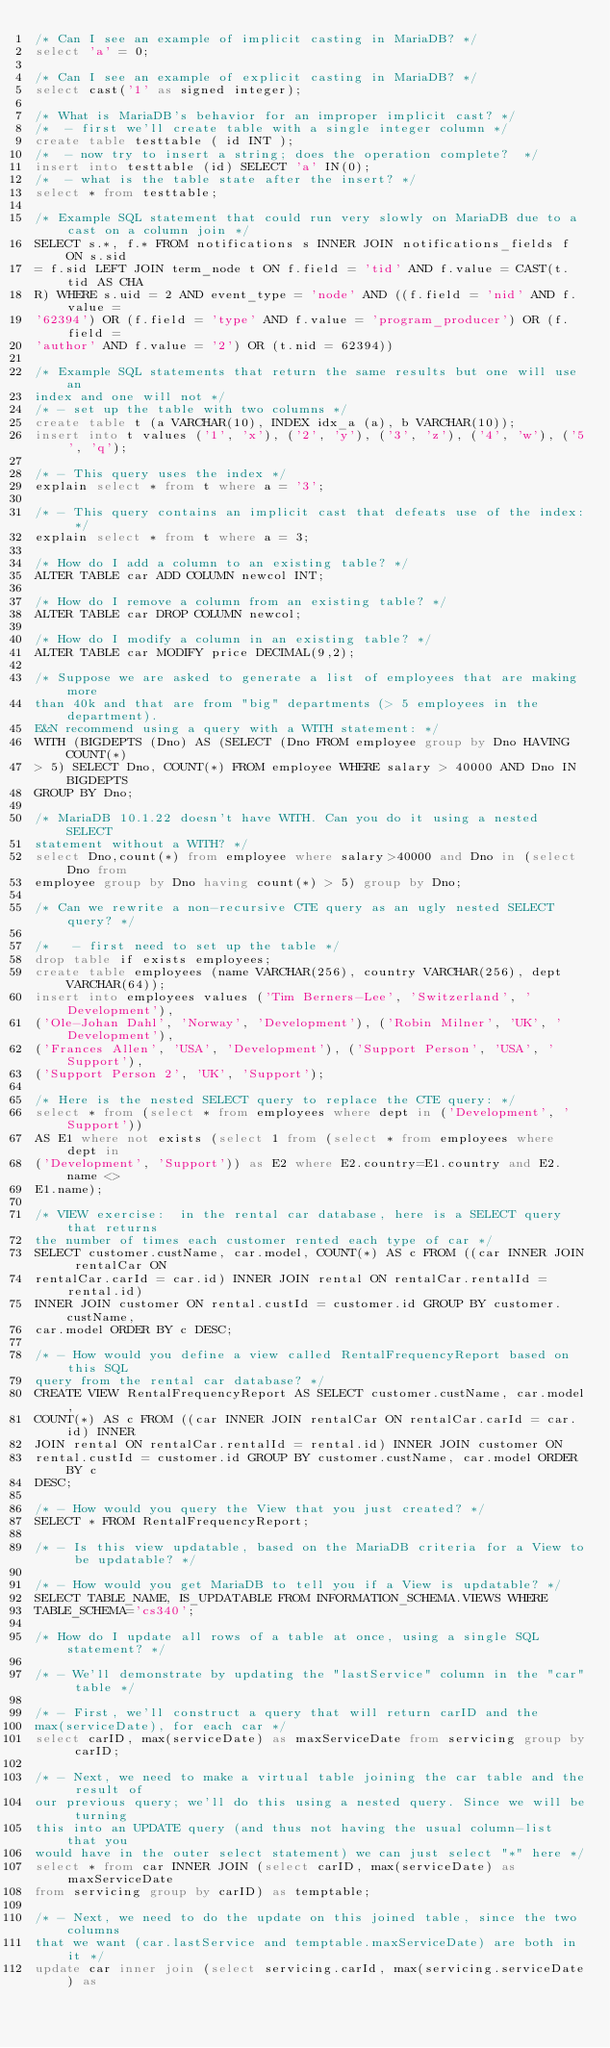<code> <loc_0><loc_0><loc_500><loc_500><_SQL_>/* Can I see an example of implicit casting in MariaDB? */
select 'a' = 0;

/* Can I see an example of explicit casting in MariaDB? */
select cast('1' as signed integer);

/* What is MariaDB's behavior for an improper implicit cast? */
/*  - first we'll create table with a single integer column */
create table testtable ( id INT );
/*  - now try to insert a string; does the operation complete?  */
insert into testtable (id) SELECT 'a' IN(0);
/*  - what is the table state after the insert? */
select * from testtable;

/* Example SQL statement that could run very slowly on MariaDB due to a cast on a column join */
SELECT s.*, f.* FROM notifications s INNER JOIN notifications_fields f ON s.sid
= f.sid LEFT JOIN term_node t ON f.field = 'tid' AND f.value = CAST(t.tid AS CHA
R) WHERE s.uid = 2 AND event_type = 'node' AND ((f.field = 'nid' AND f.value =
'62394') OR (f.field = 'type' AND f.value = 'program_producer') OR (f.field =
'author' AND f.value = '2') OR (t.nid = 62394))

/* Example SQL statements that return the same results but one will use an
index and one will not */
/* - set up the table with two columns */
create table t (a VARCHAR(10), INDEX idx_a (a), b VARCHAR(10));
insert into t values ('1', 'x'), ('2', 'y'), ('3', 'z'), ('4', 'w'), ('5', 'q');

/* - This query uses the index */
explain select * from t where a = '3';

/* - This query contains an implicit cast that defeats use of the index: */
explain select * from t where a = 3;

/* How do I add a column to an existing table? */
ALTER TABLE car ADD COLUMN newcol INT;

/* How do I remove a column from an existing table? */
ALTER TABLE car DROP COLUMN newcol;

/* How do I modify a column in an existing table? */
ALTER TABLE car MODIFY price DECIMAL(9,2);

/* Suppose we are asked to generate a list of employees that are making more
than 40k and that are from "big" departments (> 5 employees in the department).
E&N recommend using a query with a WITH statement: */
WITH (BIGDEPTS (Dno) AS (SELECT (Dno FROM employee group by Dno HAVING COUNT(*)
> 5) SELECT Dno, COUNT(*) FROM employee WHERE salary > 40000 AND Dno IN BIGDEPTS
GROUP BY Dno;

/* MariaDB 10.1.22 doesn't have WITH. Can you do it using a nested SELECT
statement without a WITH? */
select Dno,count(*) from employee where salary>40000 and Dno in (select Dno from
employee group by Dno having count(*) > 5) group by Dno;

/* Can we rewrite a non-recursive CTE query as an ugly nested SELECT query? */

/*   - first need to set up the table */
drop table if exists employees;
create table employees (name VARCHAR(256), country VARCHAR(256), dept VARCHAR(64));
insert into employees values ('Tim Berners-Lee', 'Switzerland', 'Development'),
('Ole-Johan Dahl', 'Norway', 'Development'), ('Robin Milner', 'UK', 'Development'),
('Frances Allen', 'USA', 'Development'), ('Support Person', 'USA', 'Support'),
('Support Person 2', 'UK', 'Support');

/* Here is the nested SELECT query to replace the CTE query: */
select * from (select * from employees where dept in ('Development', 'Support'))
AS E1 where not exists (select 1 from (select * from employees where dept in
('Development', 'Support')) as E2 where E2.country=E1.country and E2.name <>
E1.name);

/* VIEW exercise:  in the rental car database, here is a SELECT query that returns
the number of times each customer rented each type of car */
SELECT customer.custName, car.model, COUNT(*) AS c FROM ((car INNER JOIN rentalCar ON
rentalCar.carId = car.id) INNER JOIN rental ON rentalCar.rentalId = rental.id)
INNER JOIN customer ON rental.custId = customer.id GROUP BY customer.custName,
car.model ORDER BY c DESC;

/* - How would you define a view called RentalFrequencyReport based on this SQL
query from the rental car database? */
CREATE VIEW RentalFrequencyReport AS SELECT customer.custName, car.model,
COUNT(*) AS c FROM ((car INNER JOIN rentalCar ON rentalCar.carId = car.id) INNER
JOIN rental ON rentalCar.rentalId = rental.id) INNER JOIN customer ON
rental.custId = customer.id GROUP BY customer.custName, car.model ORDER BY c
DESC;

/* - How would you query the View that you just created? */
SELECT * FROM RentalFrequencyReport;

/* - Is this view updatable, based on the MariaDB criteria for a View to be updatable? */

/* - How would you get MariaDB to tell you if a View is updatable? */
SELECT TABLE_NAME, IS_UPDATABLE FROM INFORMATION_SCHEMA.VIEWS WHERE
TABLE_SCHEMA='cs340';

/* How do I update all rows of a table at once, using a single SQL statement? */

/* - We'll demonstrate by updating the "lastService" column in the "car" table */

/* - First, we'll construct a query that will return carID and the
max(serviceDate), for each car */
select carID, max(serviceDate) as maxServiceDate from servicing group by carID;

/* - Next, we need to make a virtual table joining the car table and the result of
our previous query; we'll do this using a nested query. Since we will be turning
this into an UPDATE query (and thus not having the usual column-list that you
would have in the outer select statement) we can just select "*" here */
select * from car INNER JOIN (select carID, max(serviceDate) as maxServiceDate
from servicing group by carID) as temptable;

/* - Next, we need to do the update on this joined table, since the two columns
that we want (car.lastService and temptable.maxServiceDate) are both in it */
update car inner join (select servicing.carId, max(servicing.serviceDate) as</code> 